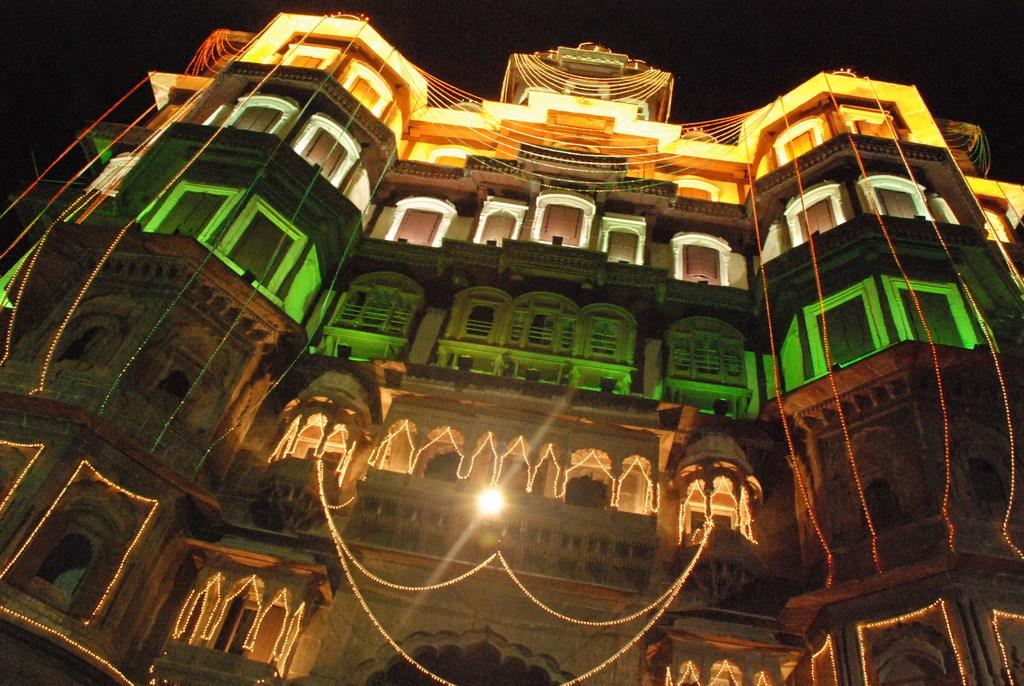What type of structure is featured in the picture? There is a historical building in the picture. Are there any additional features on the building? Yes, the building has lights on it, including decoration lights. How would you describe the sky in the background of the image? The sky behind the building is dark. What type of drug is being sold in the picture? There is no indication of any drug being sold or present in the image. The image features a historical building with lights on it and a dark sky in the background. 